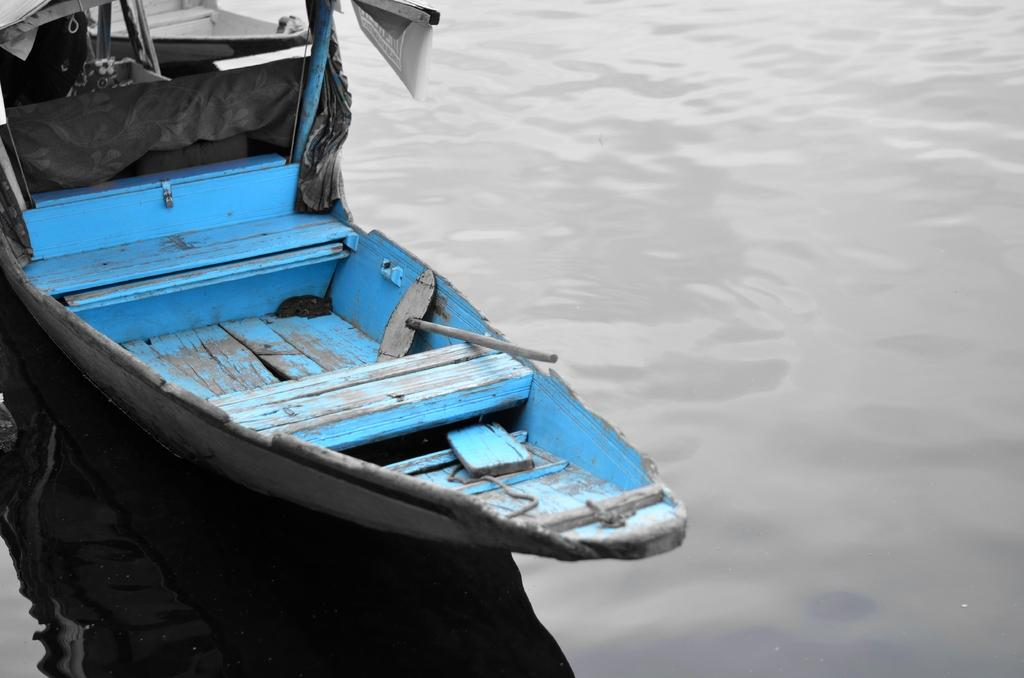What is the main subject of the image? The main subject of the image is a boat. What can be seen in the background of the image? There is water visible in the image. What type of eggnog is being served on the boat in the image? There is no eggnog present in the image; it features a boat on water. What is the tendency of the boat to move in the image? The image does not depict the boat's movement, so it is not possible to determine its tendency to move. 